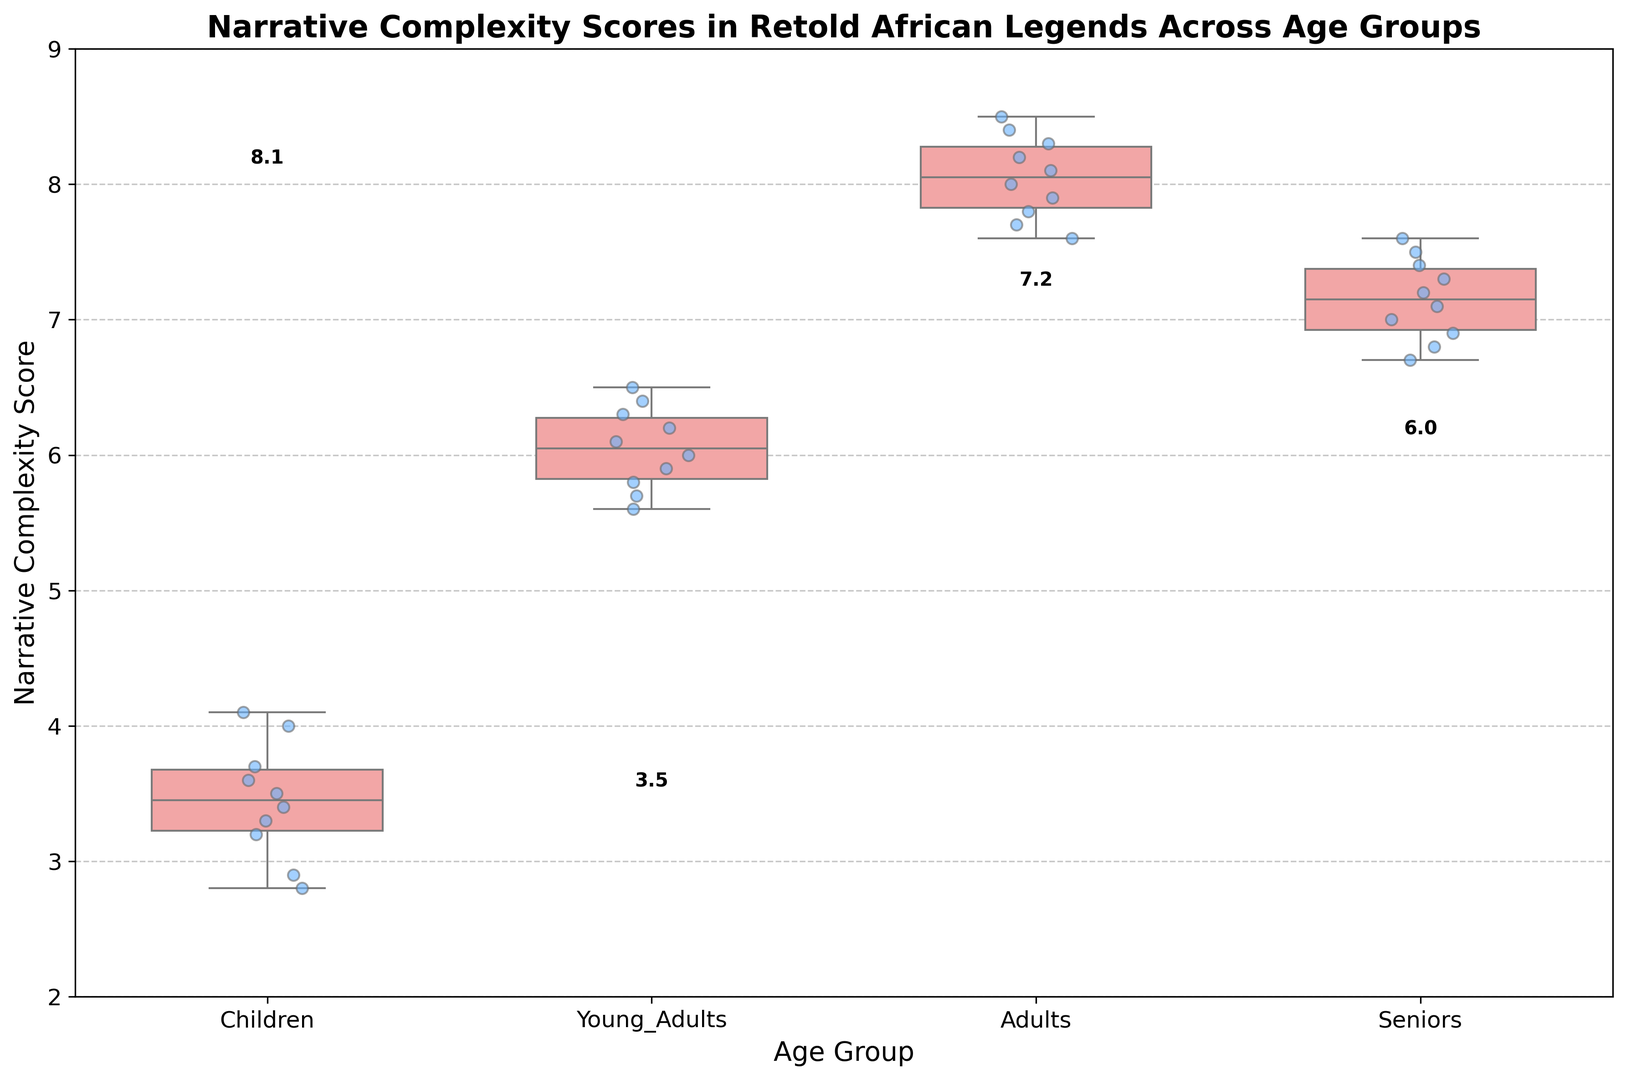What is the median Narrative Complexity Score for the Adults group? The median is the value that separates the higher half from the lower half of the data points. For the Adults group, the median score is labeled above the box plot in the figure.
Answer: 8.0 Which age group has the highest median Narrative Complexity Score? The median score for each age group is the number located above the box in each group. By comparing these values, we can identify the highest one.
Answer: Adults How does the Narrative Complexity Score for Seniors compare to that of Children? By comparing the boxes and their medians, we can observe that the Seniors group has higher Narrative Complexity Scores on average than the Children group. The median of Seniors is around 7.2, while for Children, it is around 3.5.
Answer: Seniors have higher scores Between which two age groups is the difference in median Narrative Complexity Scores the greatest? To find the greatest difference, subtract the medians of each pair and compare. The largest difference will be between Adults and Children, where Adults have a median of 8.0 and Children have 3.5.
Answer: Adults and Children What is the interquartile range (IQR) for the Young Adults group? The interquartile range is the difference between the third quartile (Q3) and the first quartile (Q1). By looking at the top and bottom edges of the box for Young Adults, we can estimate the IQR. Q3 is around 6.3 and Q1 is around 5.8, so the IQR is 6.3 - 5.8.
Answer: 0.5 Which group shows more variability in Narrative Complexity Scores, Children or Adults? Variability can be assessed by looking at the height of the box plot. The Children group's box is taller compared to the more compressed box of Adults, indicating more variability in Children.
Answer: Children Are there any outliers in the Narrative Complexity Scores for any of the age groups? Outliers are typically indicated by individual points outside the whiskers of the box plot. In this figure, there are no such points visible outside the whiskers for any group.
Answer: No What is the median Narrative Complexity Score for the Children group compared to its highest score in the same group? The median of the Children group is given as around 3.5, and the highest score is the top whisker which is around 4.1.
Answer: Median is 3.5 and highest is 4.1 